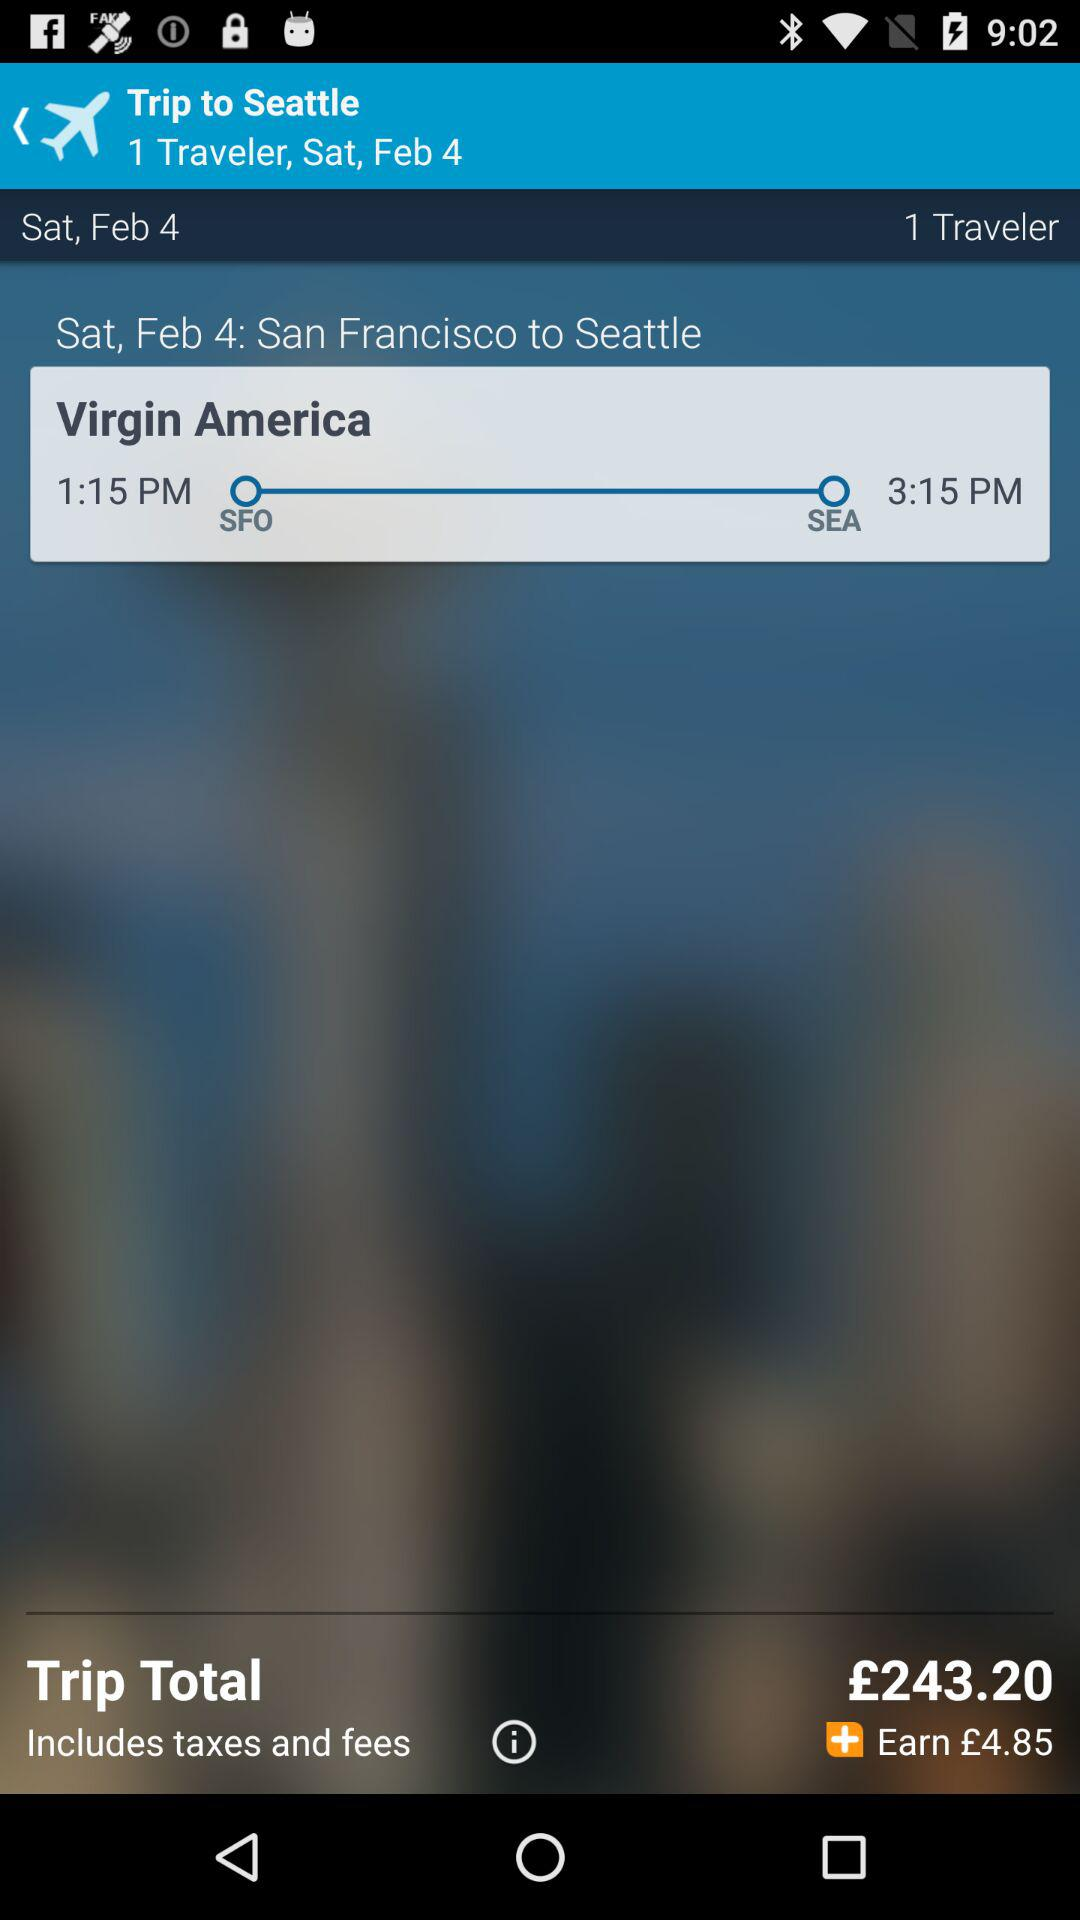What is the destination location? The destination location is Seattle. 